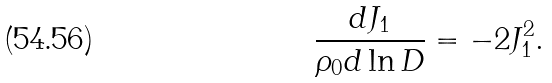Convert formula to latex. <formula><loc_0><loc_0><loc_500><loc_500>\frac { d J _ { 1 } } { \rho _ { 0 } d \ln D } = - 2 J _ { 1 } ^ { 2 } .</formula> 